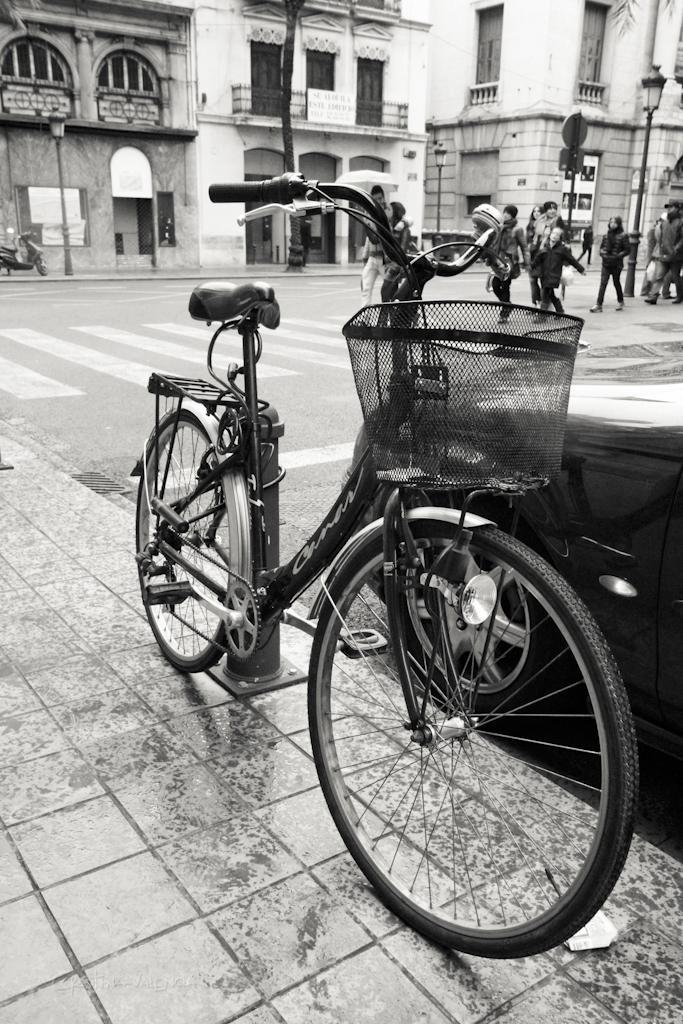How would you summarize this image in a sentence or two? This image is a black and white image. This image is taken outdoors. At the bottom of the image there is a sidewalk. In the middle of the image a bicycle is parked on the sidewalk. In the background there are a few buildings with walls, windows and doors. A bike is parked on the road. There are a few poles and signboards. A few people are walking on the road. 